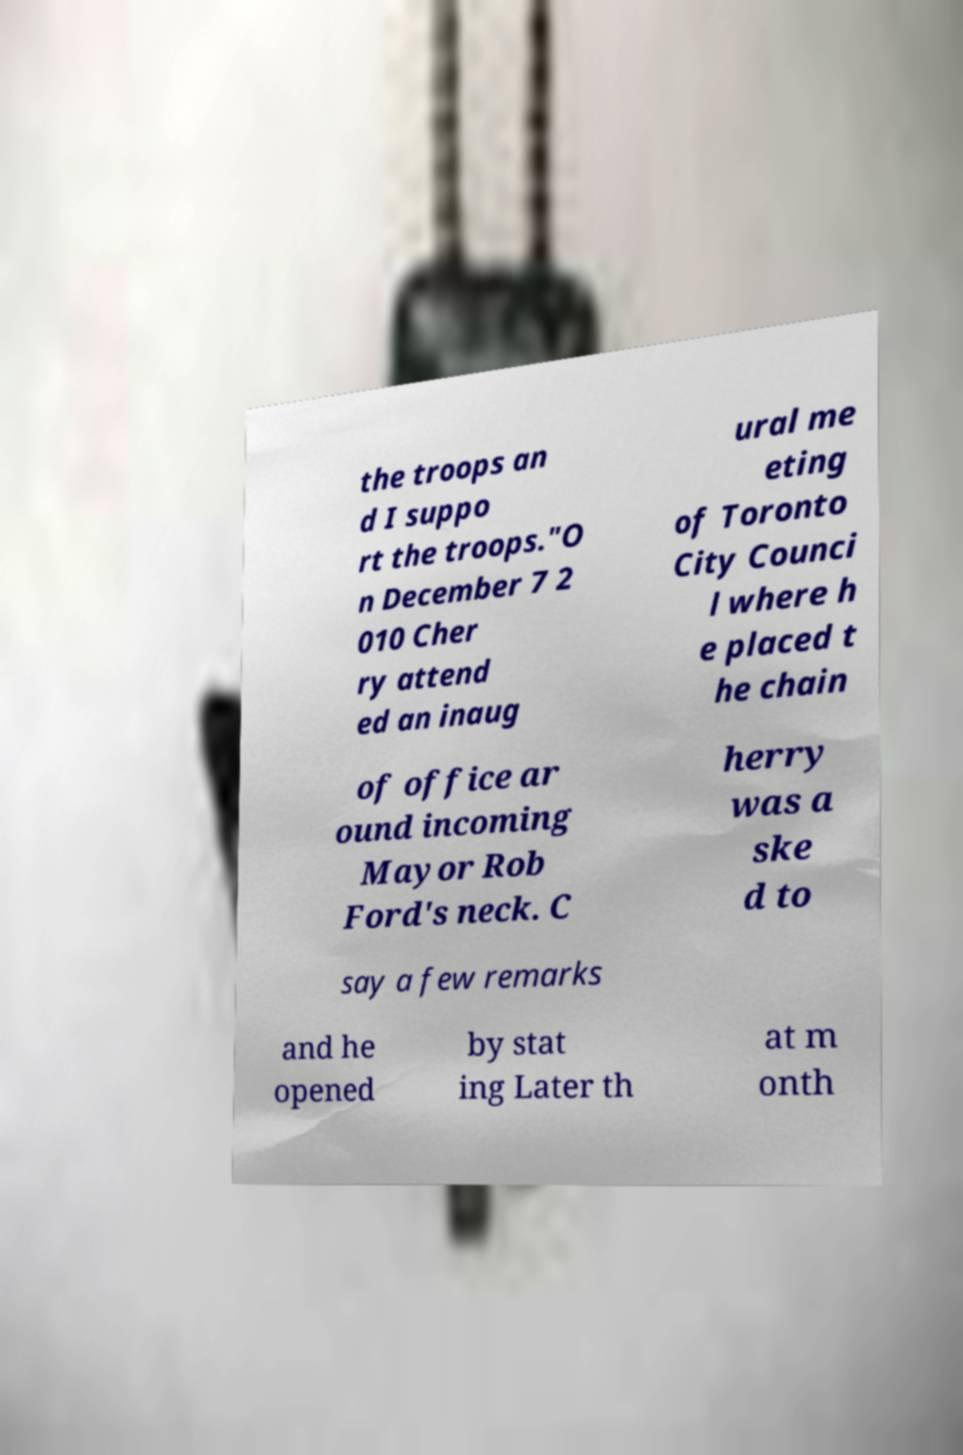Please identify and transcribe the text found in this image. the troops an d I suppo rt the troops."O n December 7 2 010 Cher ry attend ed an inaug ural me eting of Toronto City Counci l where h e placed t he chain of office ar ound incoming Mayor Rob Ford's neck. C herry was a ske d to say a few remarks and he opened by stat ing Later th at m onth 